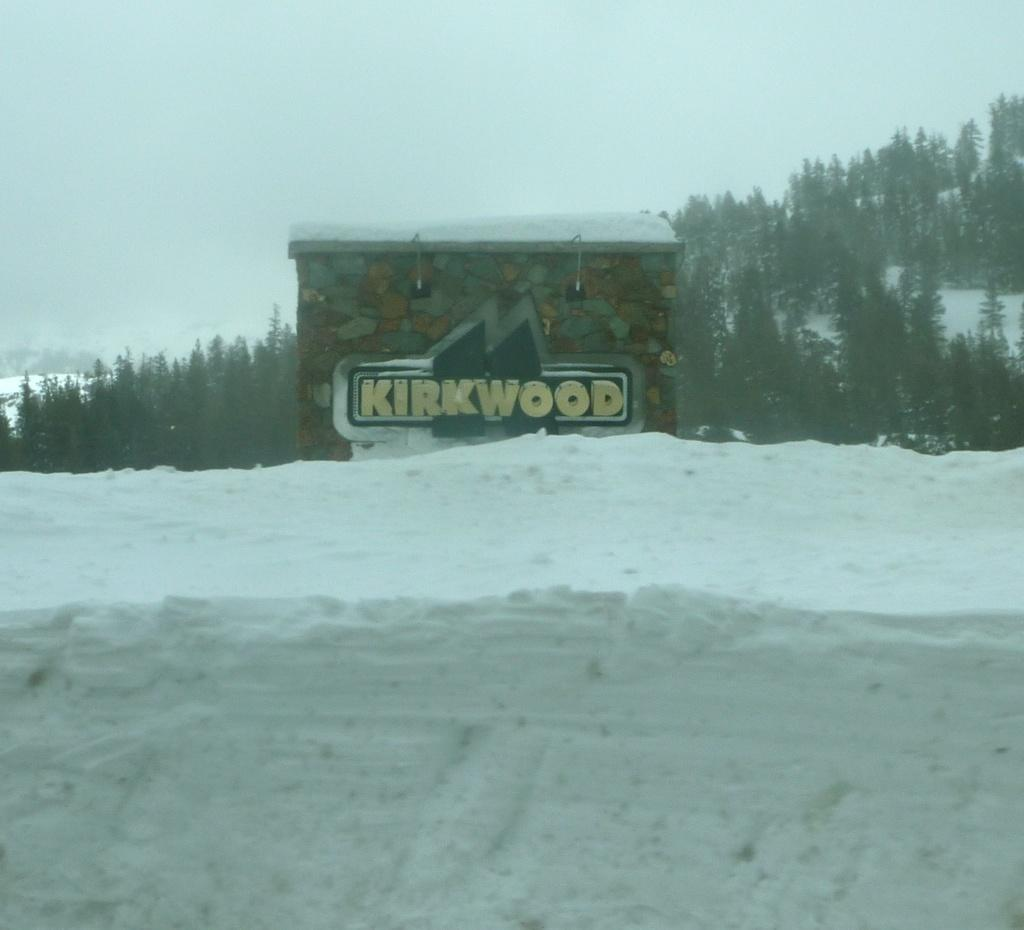What is the main subject in the center of the image? There is a house in the center of the image. Are there any words or letters in the image? Yes, there is some text in the image. What type of weather is depicted in the image? There is snow at the bottom of the image, indicating a snowy or wintery scene. What can be seen in the distance in the image? There are trees and mountains in the background of the image. Can you see the earth from the window in the image? There is no window present in the image, and therefore no view of the earth can be observed. 